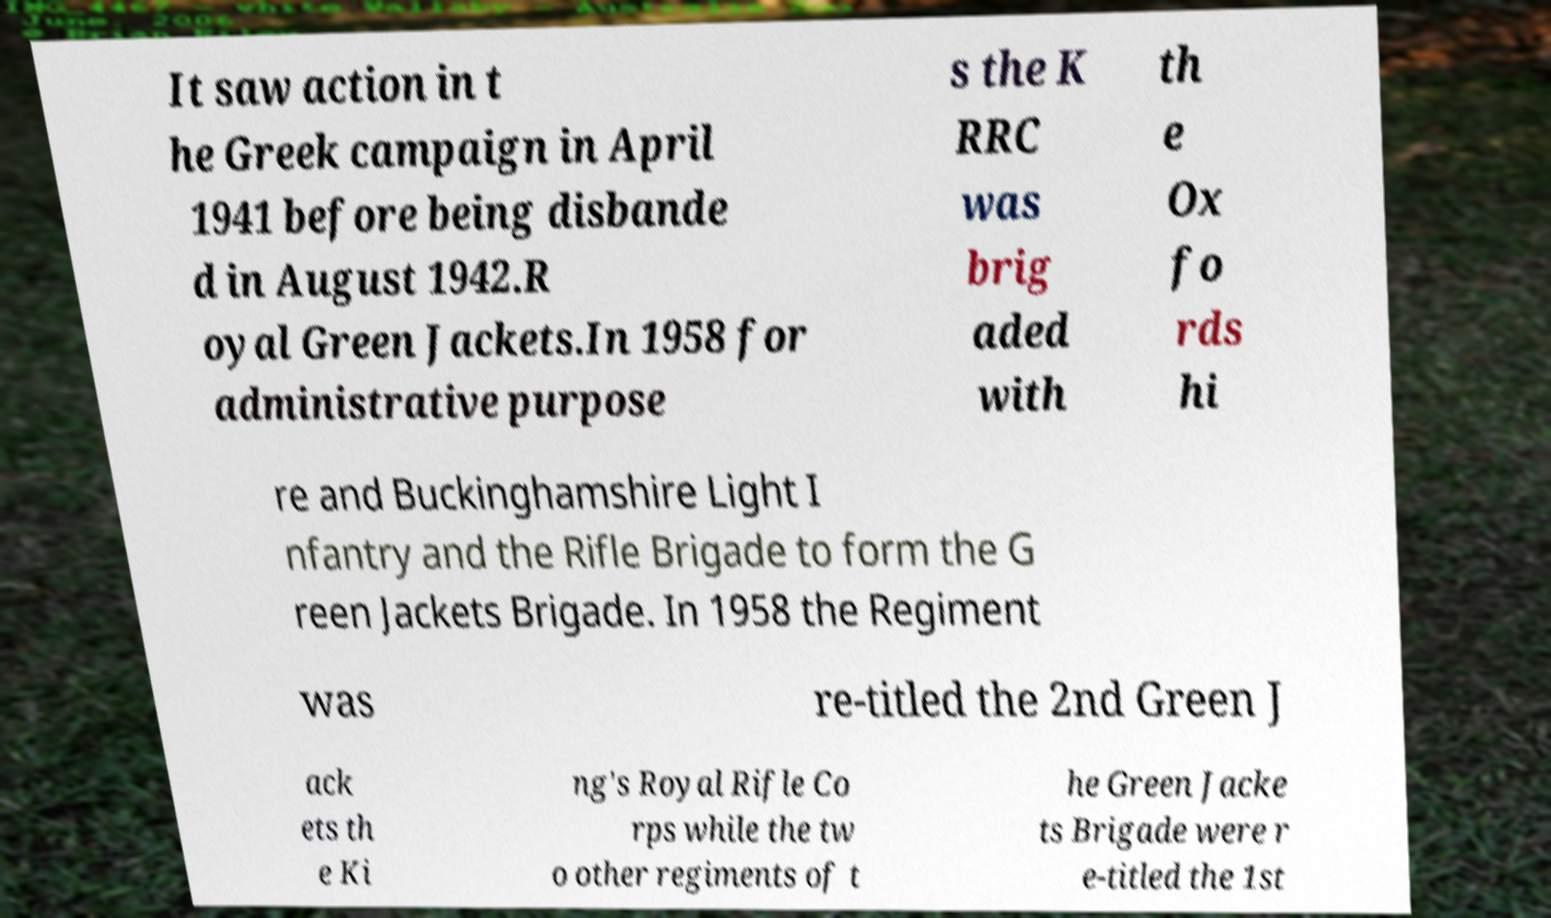What messages or text are displayed in this image? I need them in a readable, typed format. It saw action in t he Greek campaign in April 1941 before being disbande d in August 1942.R oyal Green Jackets.In 1958 for administrative purpose s the K RRC was brig aded with th e Ox fo rds hi re and Buckinghamshire Light I nfantry and the Rifle Brigade to form the G reen Jackets Brigade. In 1958 the Regiment was re-titled the 2nd Green J ack ets th e Ki ng's Royal Rifle Co rps while the tw o other regiments of t he Green Jacke ts Brigade were r e-titled the 1st 